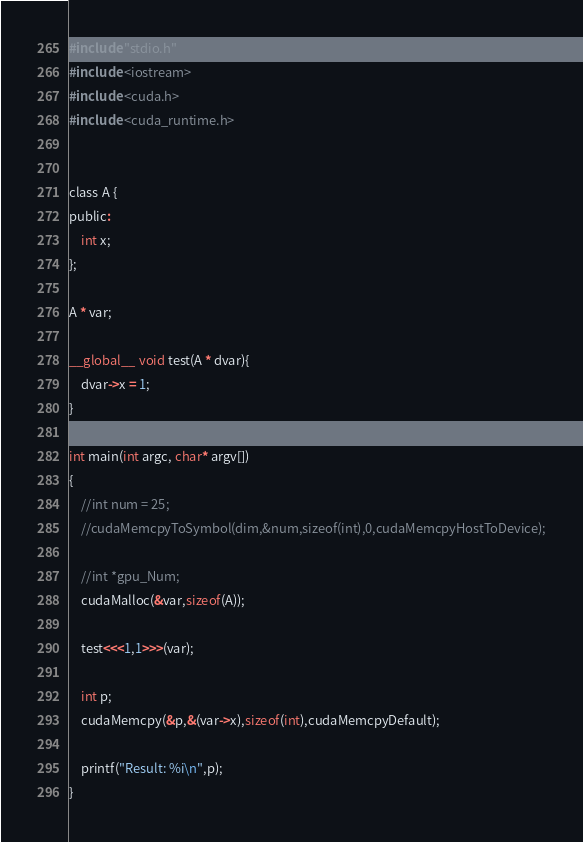<code> <loc_0><loc_0><loc_500><loc_500><_Cuda_>#include "stdio.h"
#include <iostream>
#include <cuda.h>
#include <cuda_runtime.h>


class A {
public:
	int x;
};

A * var;

__global__ void test(A * dvar){
	dvar->x = 1;
}

int main(int argc, char* argv[])
{
    //int num = 25;
    //cudaMemcpyToSymbol(dim,&num,sizeof(int),0,cudaMemcpyHostToDevice);
    
    //int *gpu_Num;
    cudaMalloc(&var,sizeof(A));

    test<<<1,1>>>(var);

	int p;
    cudaMemcpy(&p,&(var->x),sizeof(int),cudaMemcpyDefault);
    
    printf("Result: %i\n",p);
}
</code> 